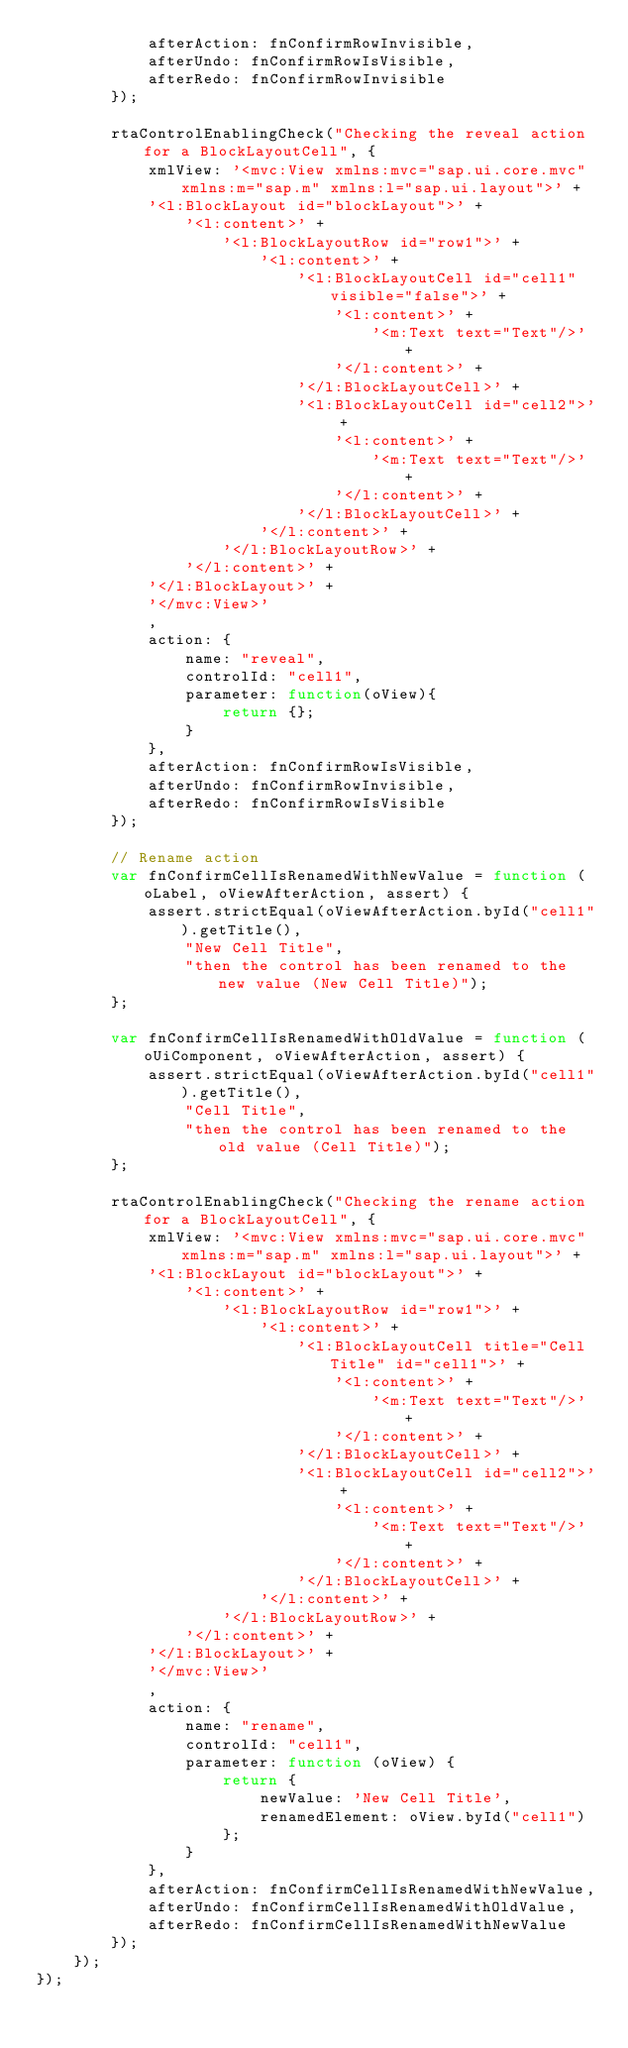<code> <loc_0><loc_0><loc_500><loc_500><_JavaScript_>			afterAction: fnConfirmRowInvisible,
			afterUndo: fnConfirmRowIsVisible,
			afterRedo: fnConfirmRowInvisible
		});

		rtaControlEnablingCheck("Checking the reveal action for a BlockLayoutCell", {
			xmlView: '<mvc:View xmlns:mvc="sap.ui.core.mvc" xmlns:m="sap.m" xmlns:l="sap.ui.layout">' +
			'<l:BlockLayout id="blockLayout">' +
				'<l:content>' +
					'<l:BlockLayoutRow id="row1">' +
						'<l:content>' +
							'<l:BlockLayoutCell id="cell1" visible="false">' +
								'<l:content>' +
									'<m:Text text="Text"/>' +
								'</l:content>' +
							'</l:BlockLayoutCell>' +
							'<l:BlockLayoutCell id="cell2">' +
								'<l:content>' +
									'<m:Text text="Text"/>' +
								'</l:content>' +
							'</l:BlockLayoutCell>' +
						'</l:content>' +
					'</l:BlockLayoutRow>' +
				'</l:content>' +
			'</l:BlockLayout>' +
			'</mvc:View>'
			,
			action: {
				name: "reveal",
				controlId: "cell1",
				parameter: function(oView){
					return {};
				}
			},
			afterAction: fnConfirmRowIsVisible,
			afterUndo: fnConfirmRowInvisible,
			afterRedo: fnConfirmRowIsVisible
		});

		// Rename action
		var fnConfirmCellIsRenamedWithNewValue = function (oLabel, oViewAfterAction, assert) {
			assert.strictEqual(oViewAfterAction.byId("cell1").getTitle(),
				"New Cell Title",
				"then the control has been renamed to the new value (New Cell Title)");
		};

		var fnConfirmCellIsRenamedWithOldValue = function (oUiComponent, oViewAfterAction, assert) {
			assert.strictEqual(oViewAfterAction.byId("cell1").getTitle(),
				"Cell Title",
				"then the control has been renamed to the old value (Cell Title)");
		};

		rtaControlEnablingCheck("Checking the rename action for a BlockLayoutCell", {
			xmlView: '<mvc:View xmlns:mvc="sap.ui.core.mvc" xmlns:m="sap.m" xmlns:l="sap.ui.layout">' +
			'<l:BlockLayout id="blockLayout">' +
				'<l:content>' +
					'<l:BlockLayoutRow id="row1">' +
						'<l:content>' +
							'<l:BlockLayoutCell title="Cell Title" id="cell1">' +
								'<l:content>' +
									'<m:Text text="Text"/>' +
								'</l:content>' +
							'</l:BlockLayoutCell>' +
							'<l:BlockLayoutCell id="cell2">' +
								'<l:content>' +
									'<m:Text text="Text"/>' +
								'</l:content>' +
							'</l:BlockLayoutCell>' +
						'</l:content>' +
					'</l:BlockLayoutRow>' +
				'</l:content>' +
			'</l:BlockLayout>' +
			'</mvc:View>'
			,
			action: {
				name: "rename",
				controlId: "cell1",
				parameter: function (oView) {
					return {
						newValue: 'New Cell Title',
						renamedElement: oView.byId("cell1")
					};
				}
			},
			afterAction: fnConfirmCellIsRenamedWithNewValue,
			afterUndo: fnConfirmCellIsRenamedWithOldValue,
			afterRedo: fnConfirmCellIsRenamedWithNewValue
		});
	});
});
</code> 